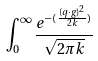Convert formula to latex. <formula><loc_0><loc_0><loc_500><loc_500>\int _ { 0 } ^ { \infty } \frac { e ^ { - ( \frac { ( q \cdot g ) ^ { 2 } } { 2 k } ) } } { \sqrt { 2 \pi k } }</formula> 